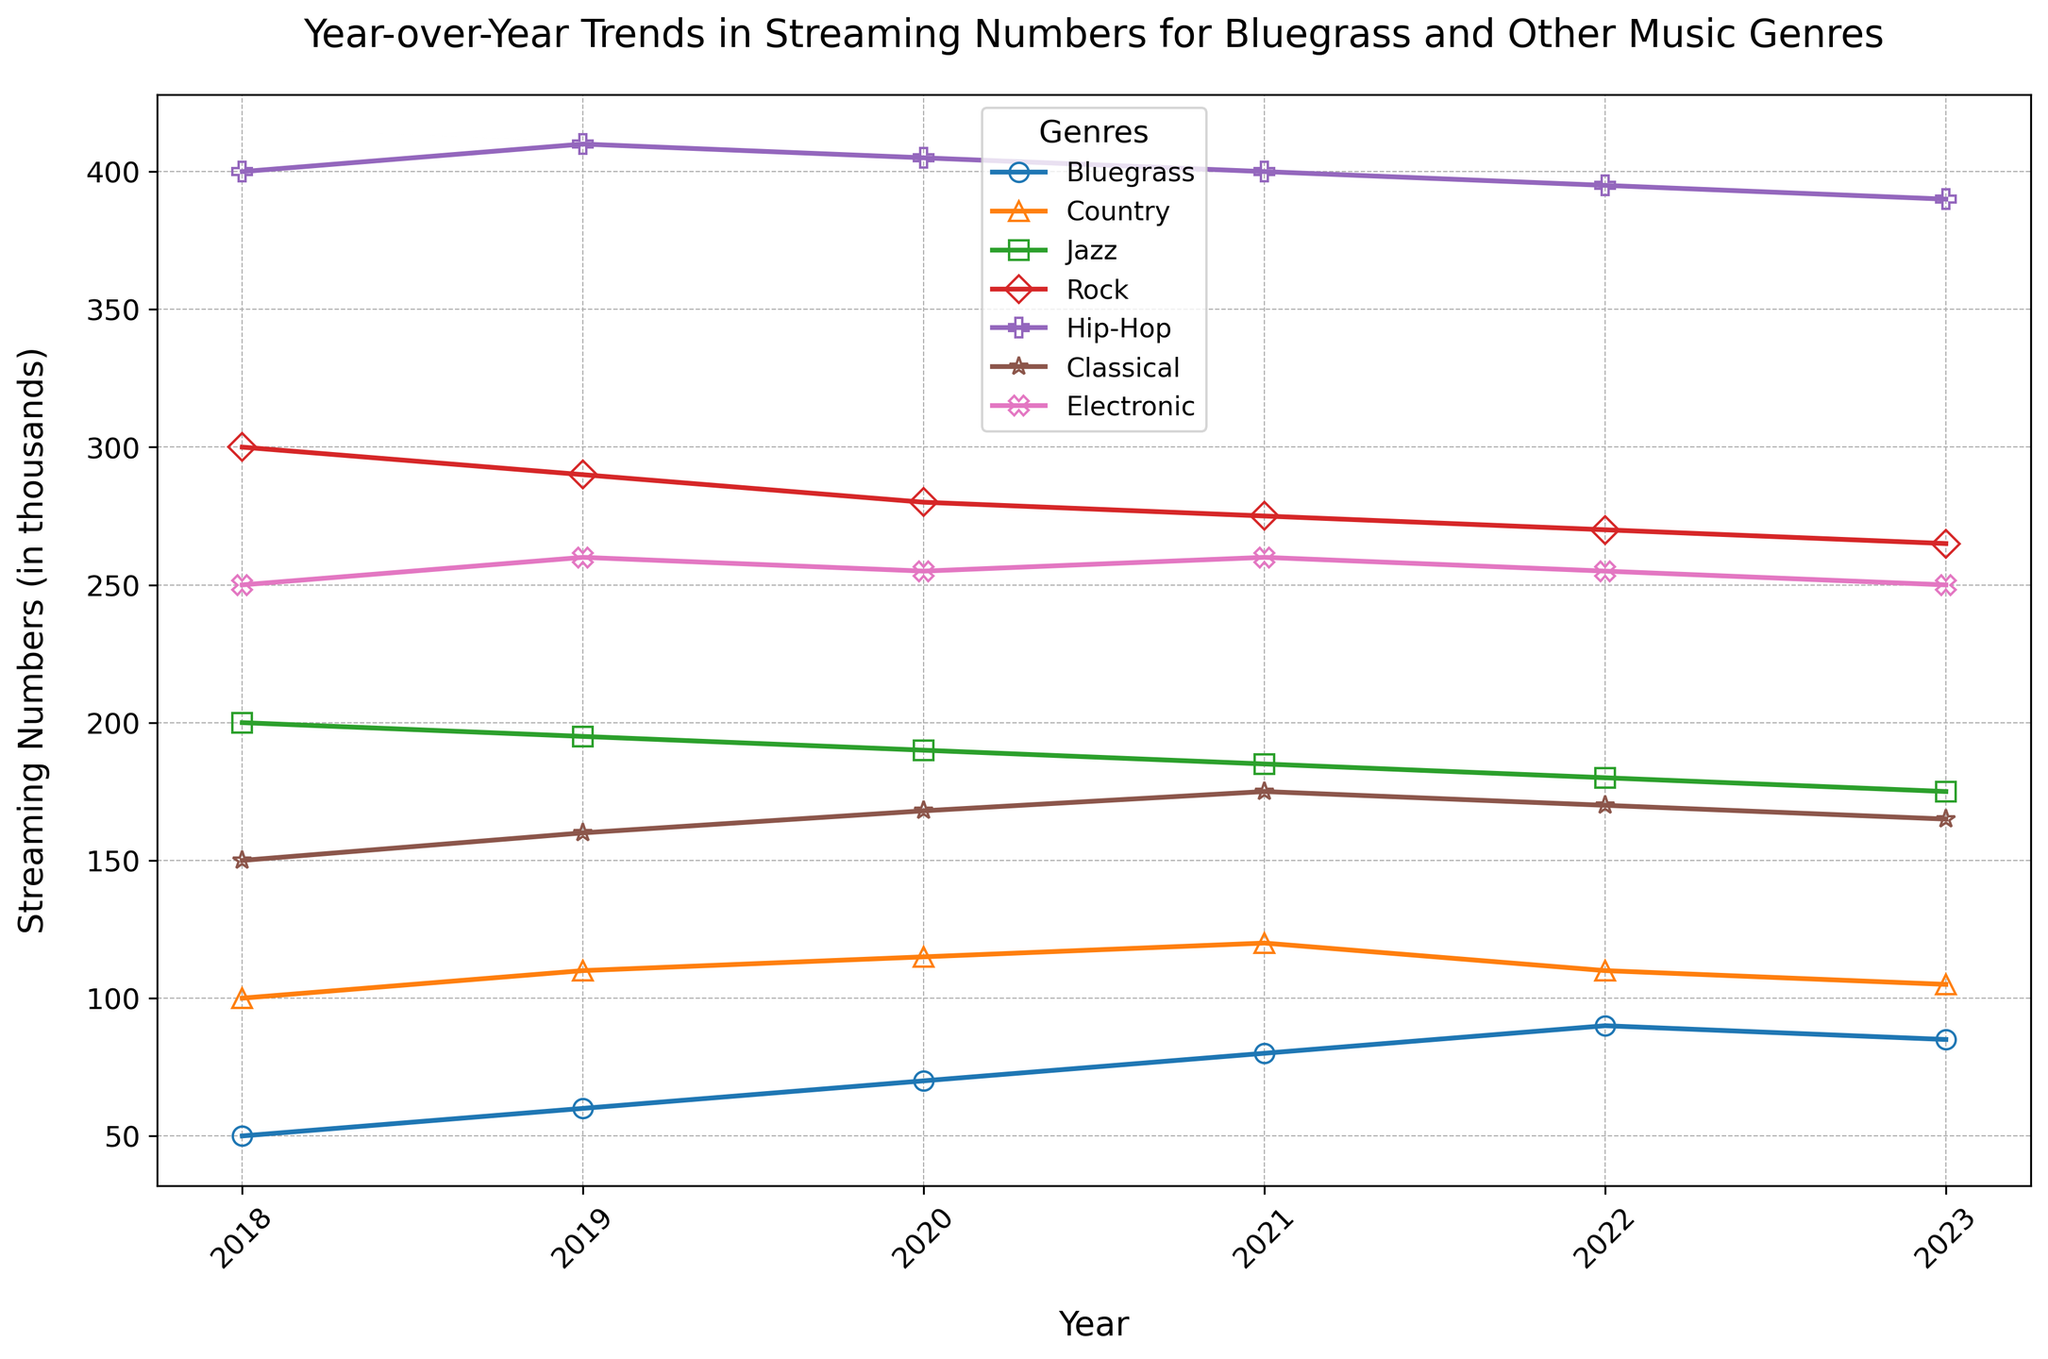Which genre shows the greatest drop in streaming numbers between 2022 and 2023? To find the greatest drop, we need to compare the differences between 2022 and 2023 for each genre. Bluegrass decreases by 5 (90 to 85), Country decreases by 5 (110 to 105), Jazz decreases by 5 (180 to 175), Rock decreases by 5 (270 to 265), Hip-Hop decreases by 5 (395 to 390), Classical decreases by 5 (170 to 165), and Electronic decreases by 5 (255 to 250). All genres show the same drop, which is 5.
Answer: Any Which genre had the highest streaming numbers in 2018? Look at the streaming numbers for each genre in 2018. The numbers are: Bluegrass = 50, Country = 100, Jazz = 200, Rock = 300, Hip-Hop = 400, Classical = 150, Electronic = 250. The highest number is 400 for Hip-Hop.
Answer: Hip-Hop What was the overall trend for Bluegrass streaming numbers from 2018 to 2023? Observe the plot line for Bluegrass from 2018 to 2023. The numbers increase from 50 in 2018 to a peak of 90 in 2022 and then slightly decline to 85 in 2023. Overall, there's a general upward trend.
Answer: Upward How do the streaming numbers of Rock in 2023 compare to its numbers in 2019? Compare the points for Rock in the years 2023 and 2019. Rock had 290 in 2019 and 265 in 2023, meaning the numbers in 2023 are lower than in 2019.
Answer: Lower Which genre had a consistent increase in streaming numbers each year from 2018 to 2021? To identify a consistent increase, check the lines. Bluegrass steadily increases from 50 in 2018 to 80 in 2021. Other genres show either decreases or inconsistency.
Answer: Bluegrass What is the average streaming number for Classical music across all presented years? Add up the streaming numbers for Classical from 2018 to 2023 (150, 160, 168, 175, 170, 165) and divide by the number of years, which is 6. (150 + 160 + 168 + 175 + 170 + 165) / 6 = 164.67
Answer: 164.67 Which two genres intersect in streaming numbers around the year 2021? Look for lines that cross around 2021. Both Classical and Electronic show similar streaming numbers around this year (175 for Classical and 260 for Electronic on either side of 2021).
Answer: Classical and Electronic By what percentage did Hip-Hop streaming numbers decrease from 2020 to 2023? Calculate the percentage decrease: ((405 - 390) / 405) * 100 = 3.7%
Answer: 3.7% Does Bluegrass or Jazz exhibit a steeper decline in streaming numbers from 2022 to 2023? Compare the slopes of the lines for Bluegrass (90 to 85) and Jazz (180 to 175) between 2022 and 2023. Both lines have the same numerical decline (both decrease by 5), so neither exhibits a steeper decline.
Answer: Neither 